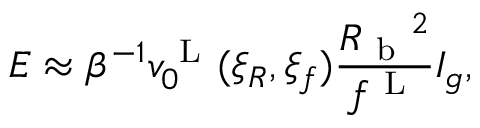Convert formula to latex. <formula><loc_0><loc_0><loc_500><loc_500>E \approx \beta ^ { - 1 } v _ { 0 } ^ { L } ( \xi _ { R } , \xi _ { f } ) \frac { { R _ { b } } ^ { 2 } } { f ^ { L } } I _ { g } ,</formula> 